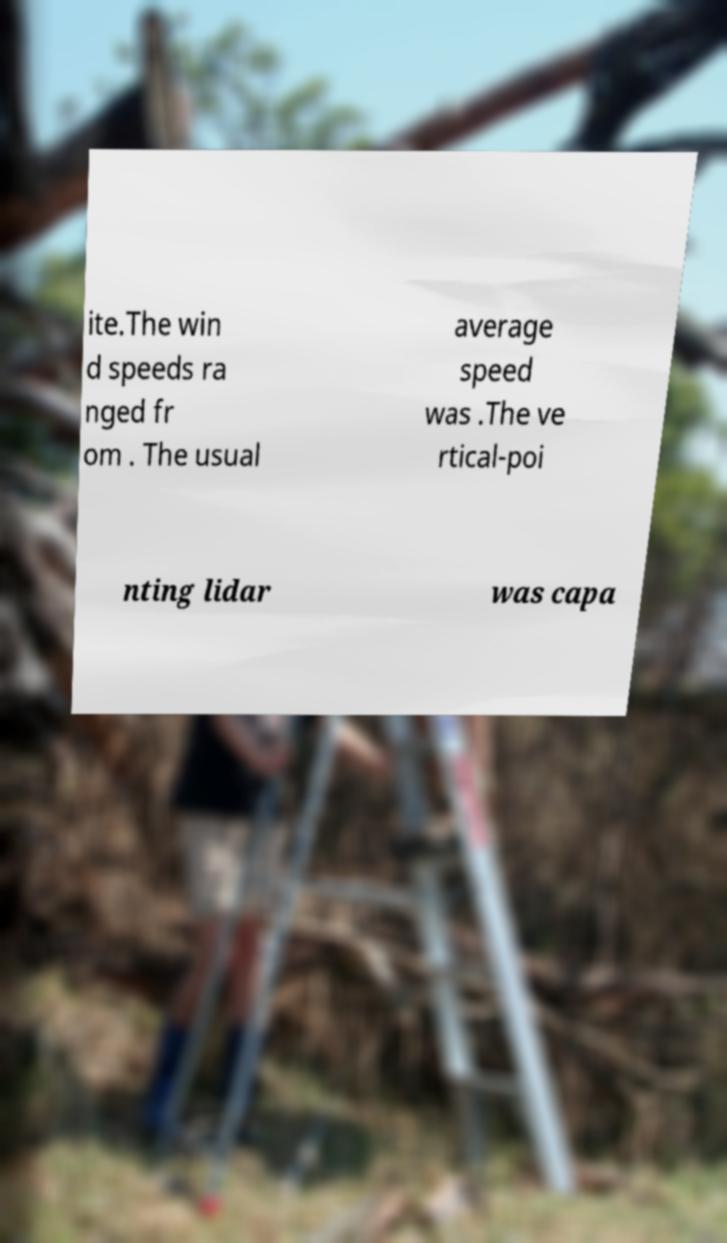Please read and relay the text visible in this image. What does it say? ite.The win d speeds ra nged fr om . The usual average speed was .The ve rtical-poi nting lidar was capa 